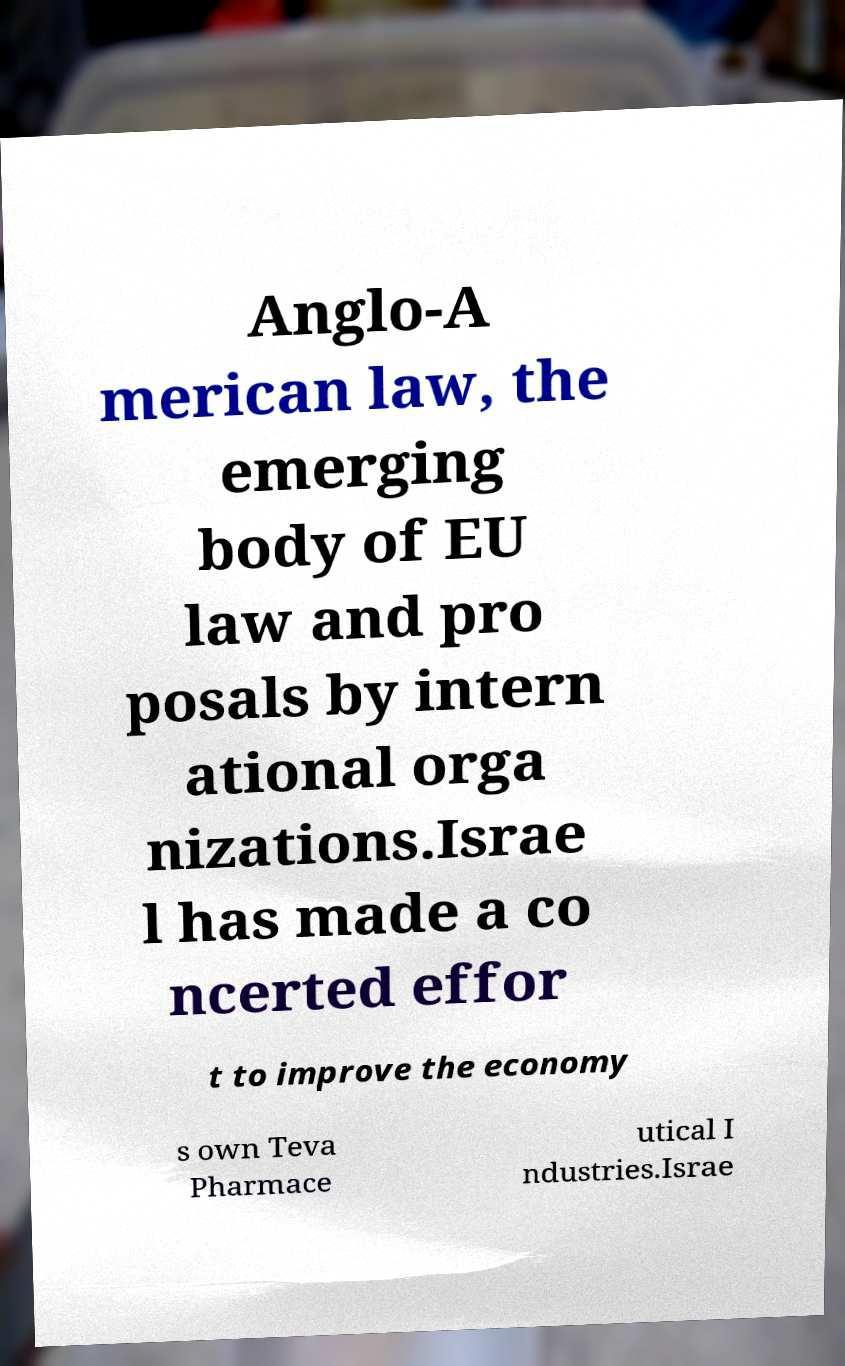I need the written content from this picture converted into text. Can you do that? Anglo-A merican law, the emerging body of EU law and pro posals by intern ational orga nizations.Israe l has made a co ncerted effor t to improve the economy s own Teva Pharmace utical I ndustries.Israe 